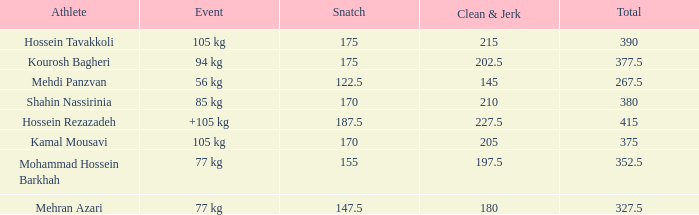What occurrence has a 12 56 kg. 